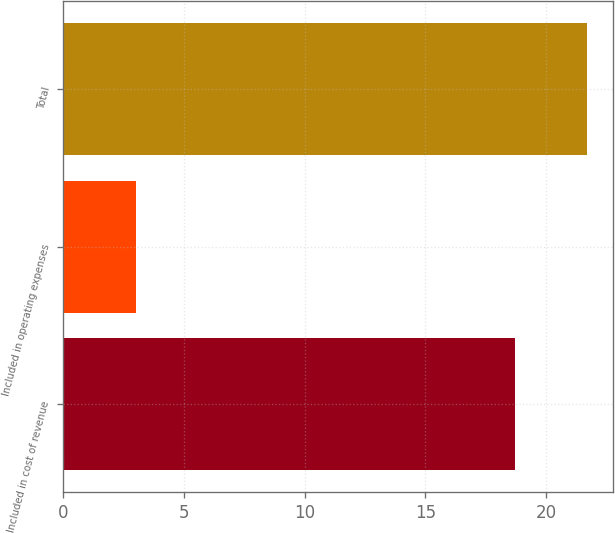Convert chart. <chart><loc_0><loc_0><loc_500><loc_500><bar_chart><fcel>Included in cost of revenue<fcel>Included in operating expenses<fcel>Total<nl><fcel>18.7<fcel>3<fcel>21.7<nl></chart> 